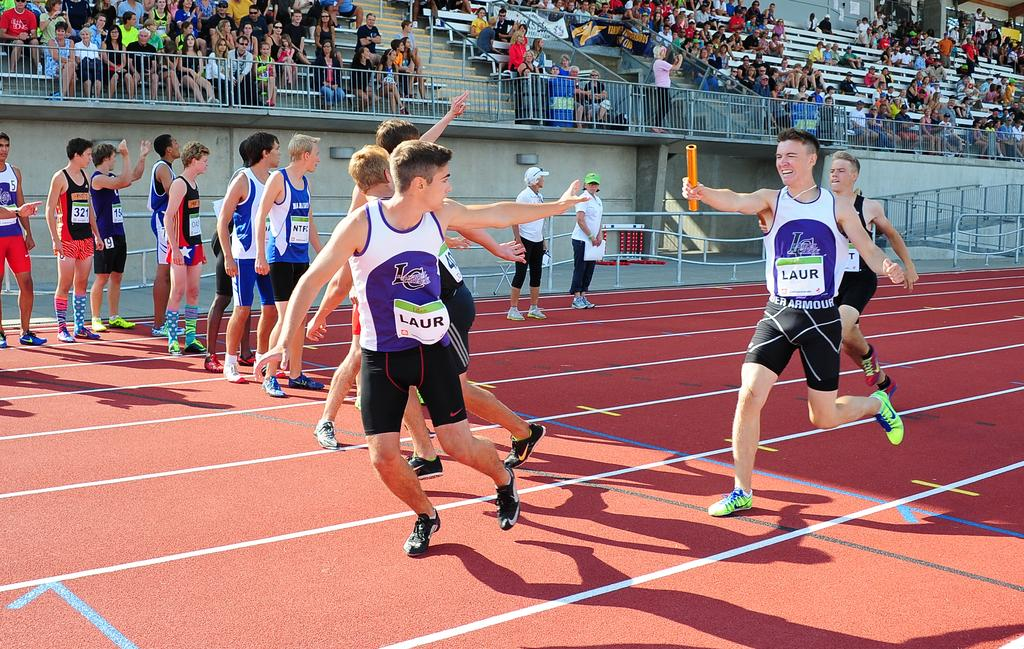Provide a one-sentence caption for the provided image. A young male wearing Under Armour shorts holds an orange baton. 